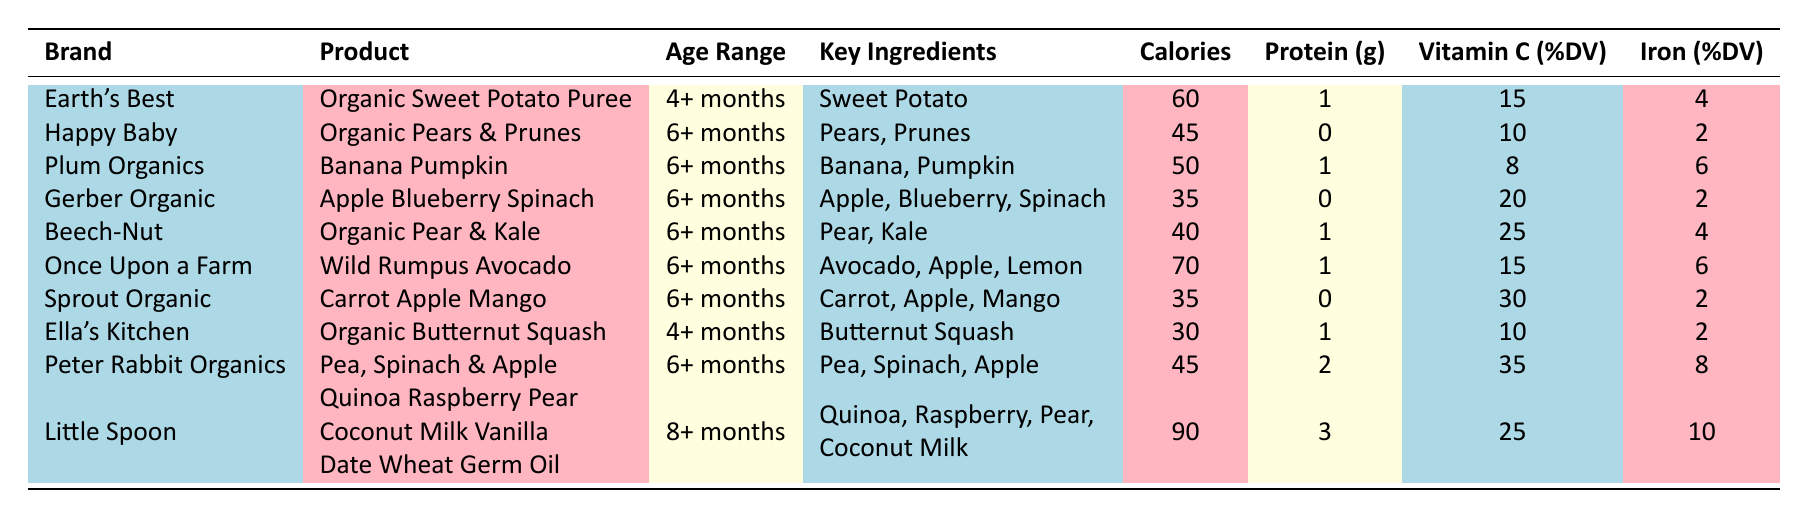What brand offers a product for 4+ months? By scanning the "Age Range" column for "4+ months," I see two products: "Organic Sweet Potato Puree" by Earth's Best and "Organic Butternut Squash" by Ella's Kitchen. Thus, the brand offering a product for this age range is Earth's Best.
Answer: Earth's Best Which product has the highest protein content? Looking at the "Protein (g)" column, I find the highest value is 3 grams in "Quinoa Raspberry Pear Coconut Milk Vanilla Date Wheat Germ Oil" from Little Spoon.
Answer: Quinoa Raspberry Pear Coconut Milk Vanilla Date Wheat Germ Oil Is there a product with 0 grams of protein? By reviewing the "Protein (g)" column, I see three products with 0 grams of protein: "Organic Pears & Prunes" by Happy Baby, "Apple Blueberry Spinach" by Gerber Organic, and "Carrot Apple Mango" by Sprout Organic. Therefore, the answer is yes.
Answer: Yes What is the average calorie content of the products listed for 6+ months? To find the average calorie content for products suitable for 6+ months, I look at the calorie values: 45, 50, 35, 40, 70, 35, 45, which sum to 320. There are eight data points, so the average is 320 divided by 8, which equals 40. The average calorie content is 40.
Answer: 40 Which product has the highest percentage of Iron? By examining the "Iron (%DV)" column, I find the highest value is 10% in "Quinoa Raspberry Pear Coconut Milk Vanilla Date Wheat Germ Oil" by Little Spoon.
Answer: Quinoa Raspberry Pear Coconut Milk Vanilla Date Wheat Germ Oil How many products have 15% or more Vitamin C? Looking at the "Vitamin C (%DV)" column, I find the following values: 15, 10, 8, 20, 25, 15, 30, 10, 35, 25. The values of 15% or more are 15, 20, 25, 15, 30, 35, and 25 which gives a total of 7 products.
Answer: 7 Are there any products that are suitable for 8+ months? Looking in the "Age Range" column, I find "Quinoa Raspberry Pear Coconut Milk Vanilla Date Wheat Germ Oil" is the only product listed for 8+ months. Therefore, the answer is yes.
Answer: Yes What are the key ingredients of 'Organic Sweet Potato Puree'? Checking the "Key Ingredients" column for "Organic Sweet Potato Puree," I see that the key ingredient is "Sweet Potato."
Answer: Sweet Potato Calculate the difference in calories between the product with the most and least calories. The highest calorie product is "Quinoa Raspberry Pear Coconut Milk Vanilla Date Wheat Germ Oil" with 90 calories, and the lowest is "Organic Butternut Squash" with 30 calories. The difference is 90 - 30 = 60.
Answer: 60 